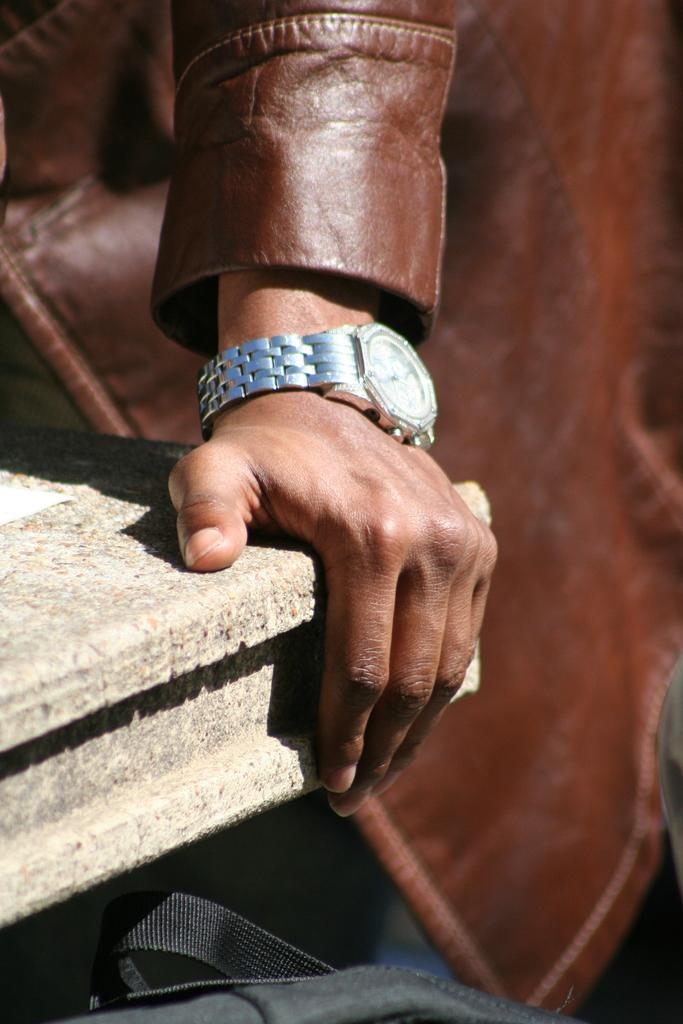What can be seen in the image? There is a person in the image. What is the person wearing? The person is wearing a brown jacket. What is the person holding? The person is holding an object. Can you describe any accessories the person is wearing? There is a silver watch on the person's left hand. What else is visible at the bottom of the image? There is a bag at the bottom of the image. What type of paint is being used on the playground in the image? There is no playground or paint present in the image. Can you compare the person's jacket to another jacket in the image? There is only one person in the image, so there is no other jacket to compare it to. 